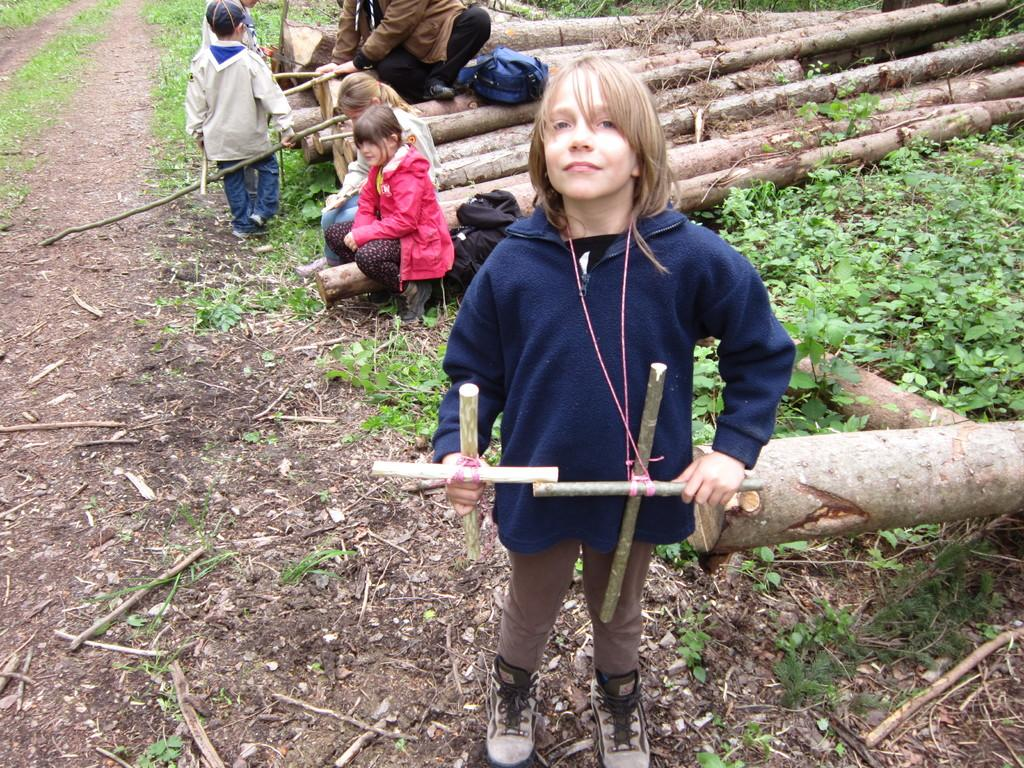How many people are present in the image? There are three persons in the image. What are the people in the image doing? Three persons are standing, and three are sitting on wooden logs in the image. What can be seen in the image besides the people? There are bags visible in the image. What type of vegetation is on the right side of the image? There are plants on the right side of the image. What type of dinosaurs can be seen roaming in the background of the image? There are no dinosaurs present in the image; it features people standing and sitting, bags, and plants. Can you tell me how many chickens are visible in the image? There are no chickens present in the image. 